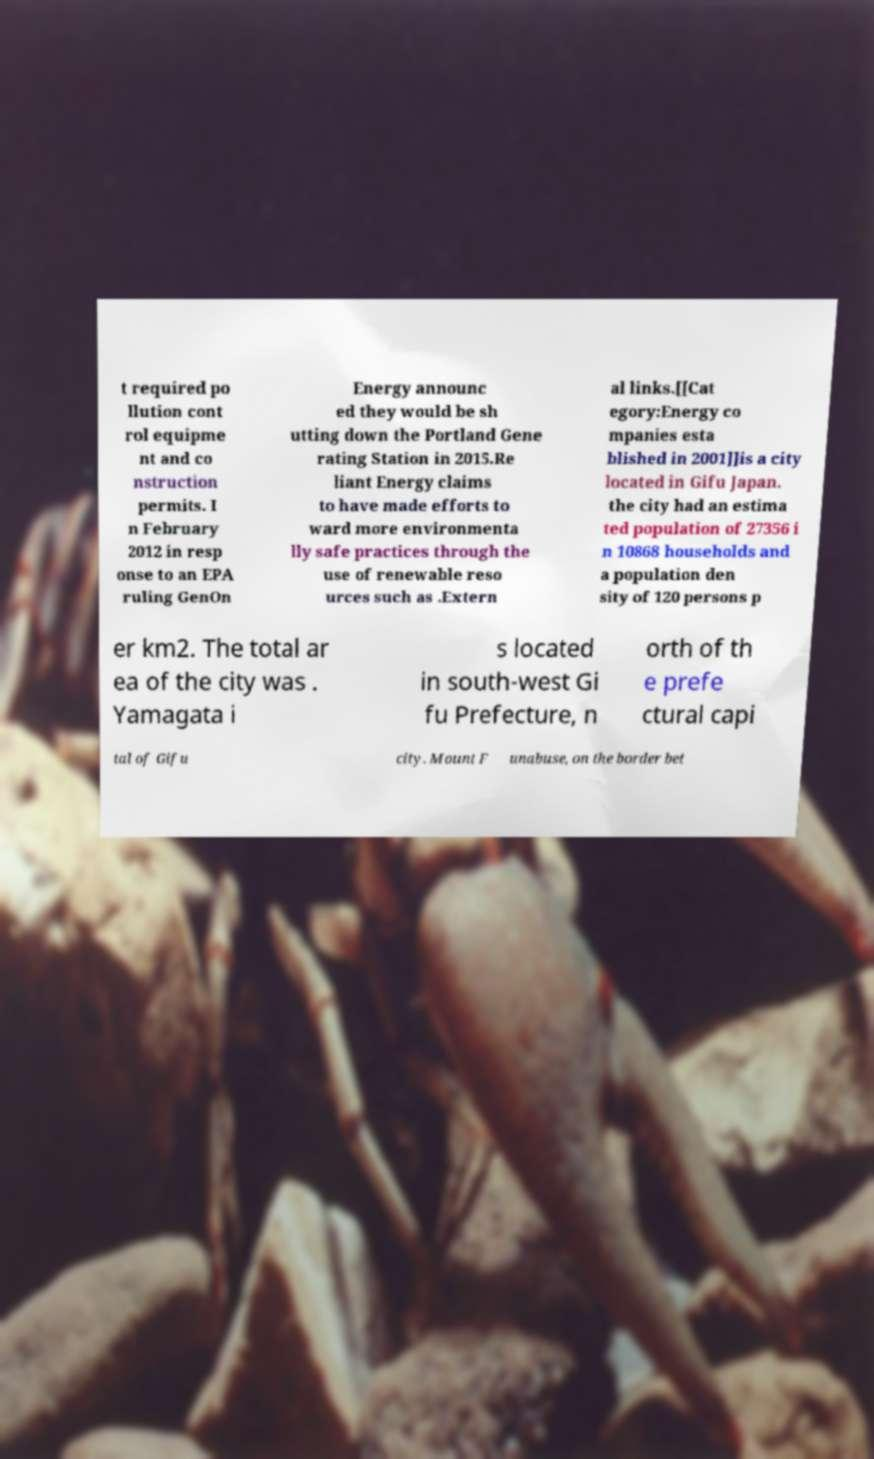Please read and relay the text visible in this image. What does it say? t required po llution cont rol equipme nt and co nstruction permits. I n February 2012 in resp onse to an EPA ruling GenOn Energy announc ed they would be sh utting down the Portland Gene rating Station in 2015.Re liant Energy claims to have made efforts to ward more environmenta lly safe practices through the use of renewable reso urces such as .Extern al links.[[Cat egory:Energy co mpanies esta blished in 2001]]is a city located in Gifu Japan. the city had an estima ted population of 27356 i n 10868 households and a population den sity of 120 persons p er km2. The total ar ea of the city was . Yamagata i s located in south-west Gi fu Prefecture, n orth of th e prefe ctural capi tal of Gifu city. Mount F unabuse, on the border bet 